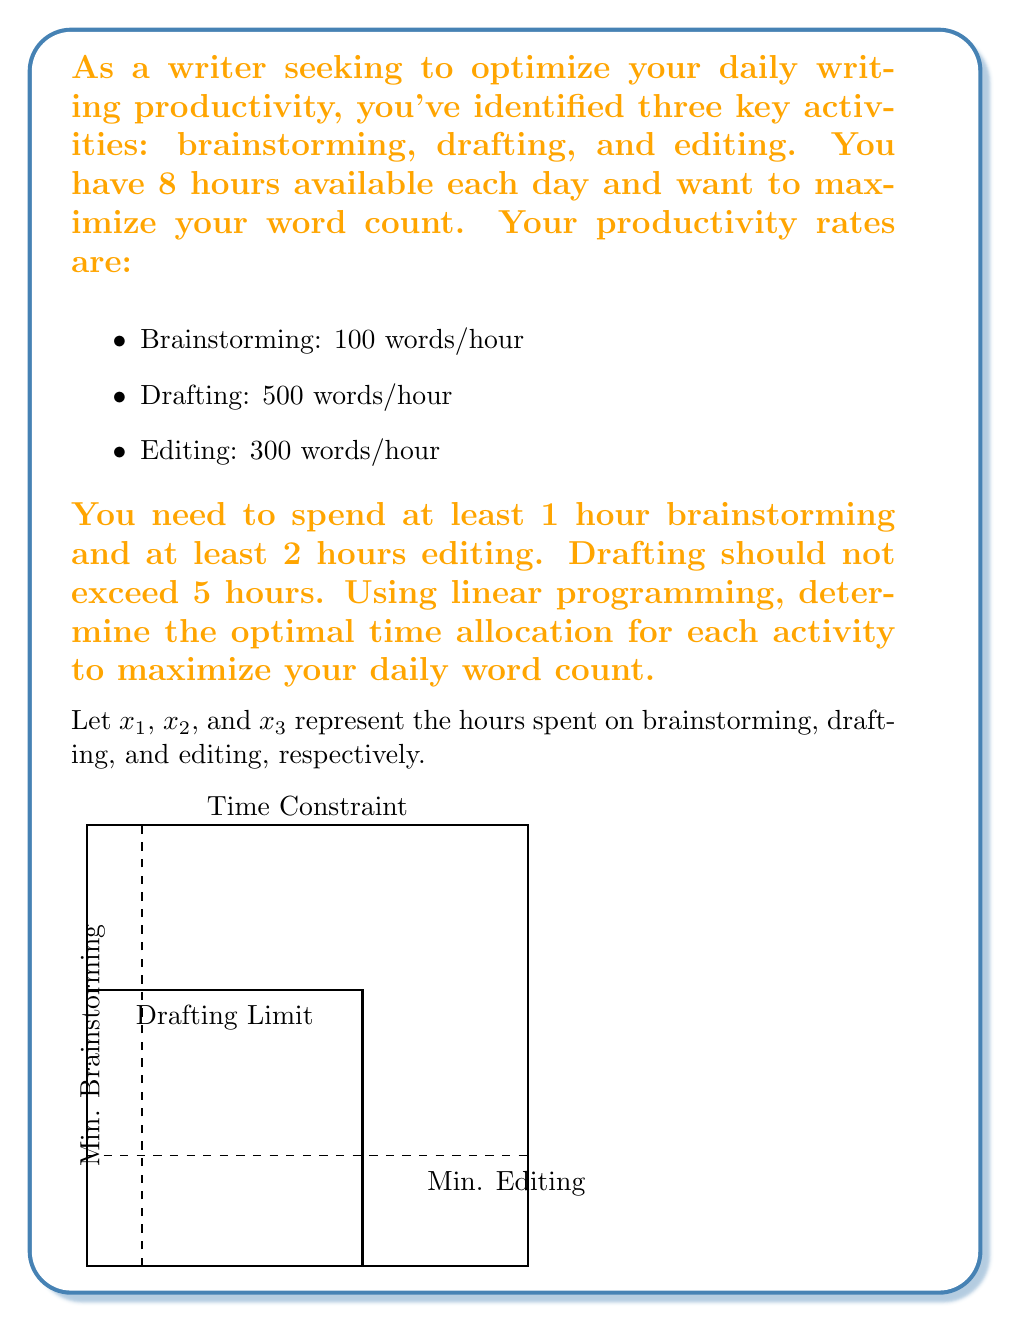Solve this math problem. Let's solve this problem step by step using linear programming:

1) Define the objective function:
   Maximize $Z = 100x_1 + 500x_2 + 300x_3$

2) Identify the constraints:
   a) Time constraint: $x_1 + x_2 + x_3 \leq 8$
   b) Minimum brainstorming: $x_1 \geq 1$
   c) Minimum editing: $x_3 \geq 2$
   d) Maximum drafting: $x_2 \leq 5$
   e) Non-negativity: $x_1, x_2, x_3 \geq 0$

3) Set up the linear program:
   Maximize $Z = 100x_1 + 500x_2 + 300x_3$
   Subject to:
   $$\begin{align}
   x_1 + x_2 + x_3 &\leq 8 \\
   x_1 &\geq 1 \\
   x_3 &\geq 2 \\
   x_2 &\leq 5 \\
   x_1, x_2, x_3 &\geq 0
   \end{align}$$

4) Solve using the simplex method or graphical method. In this case, we can deduce the solution:
   - We should maximize drafting (highest productivity) up to its limit: $x_2 = 5$
   - We need to meet minimum requirements for brainstorming and editing: $x_1 = 1$, $x_3 = 2$
   - This allocation satisfies all constraints: $1 + 5 + 2 = 8$ hours

5) Calculate the maximum word count:
   $Z = 100(1) + 500(5) + 300(2) = 3100$ words

Therefore, the optimal time allocation is:
- Brainstorming: 1 hour
- Drafting: 5 hours
- Editing: 2 hours
Answer: Brainstorming: 1 hour, Drafting: 5 hours, Editing: 2 hours; Max word count: 3100 